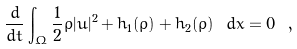<formula> <loc_0><loc_0><loc_500><loc_500>\frac { d } { d t } \int _ { \Omega } \frac { 1 } { 2 } \bar { \rho } | \bar { u } | ^ { 2 } + h _ { 1 } ( \bar { \rho } ) + h _ { 2 } ( \bar { \rho } ) \ d x = 0 \ ,</formula> 